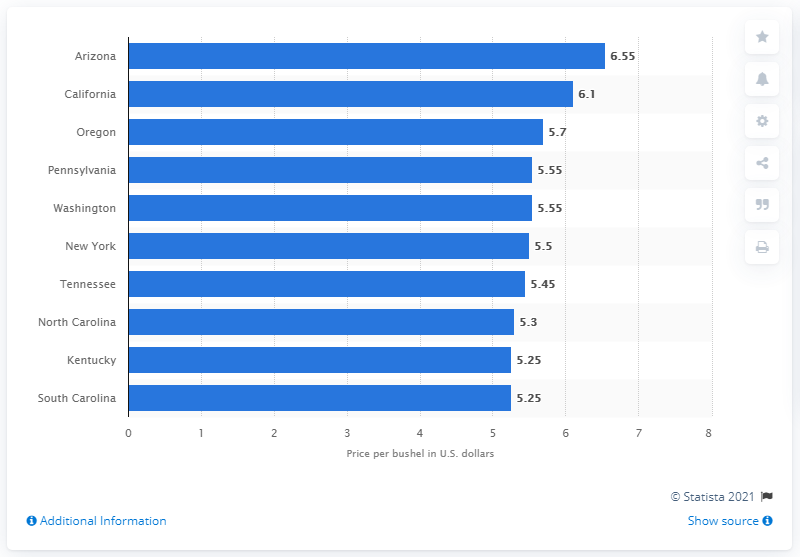What was Arizona's average price per bushel of wheat? In 2021, Arizona's average price per bushel of wheat was $6.55, which was the highest among the states listed in the dataset. 